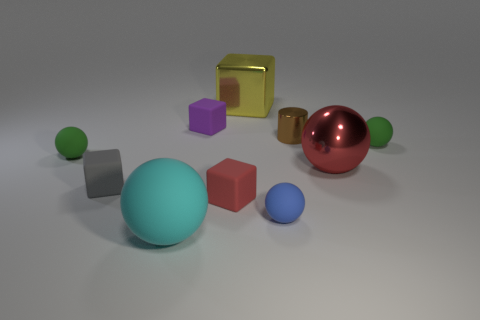Subtract 2 spheres. How many spheres are left? 3 Subtract all red balls. How many balls are left? 4 Subtract all tiny blue matte spheres. How many spheres are left? 4 Subtract all yellow spheres. Subtract all gray cubes. How many spheres are left? 5 Subtract all cubes. How many objects are left? 6 Subtract 1 cyan spheres. How many objects are left? 9 Subtract all blue shiny cubes. Subtract all red rubber things. How many objects are left? 9 Add 1 tiny cubes. How many tiny cubes are left? 4 Add 5 brown matte balls. How many brown matte balls exist? 5 